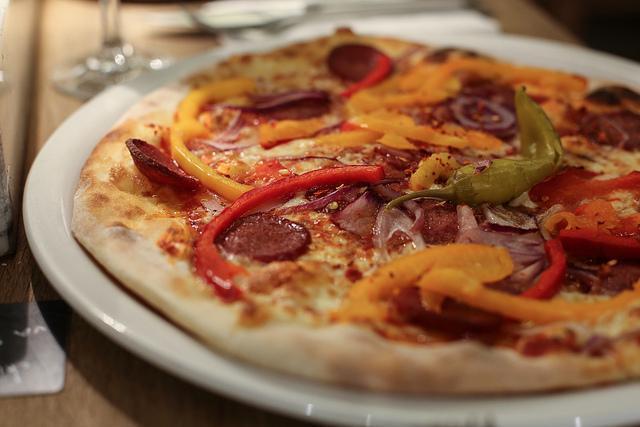How many sinks are in there?
Give a very brief answer. 0. 